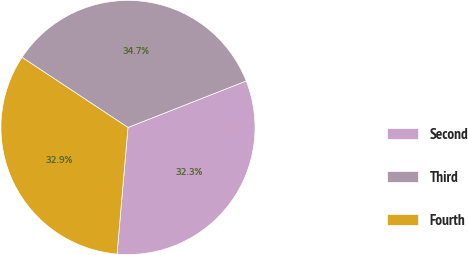<chart> <loc_0><loc_0><loc_500><loc_500><pie_chart><fcel>Second<fcel>Third<fcel>Fourth<nl><fcel>32.34%<fcel>34.73%<fcel>32.93%<nl></chart> 